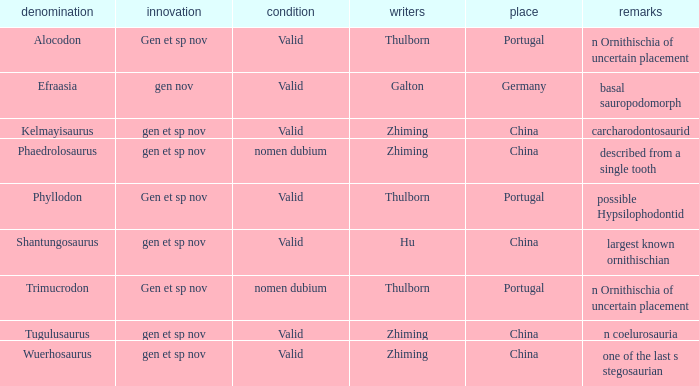What is the Novelty of the dinosaur, whose naming Author was Galton? Gen nov. 